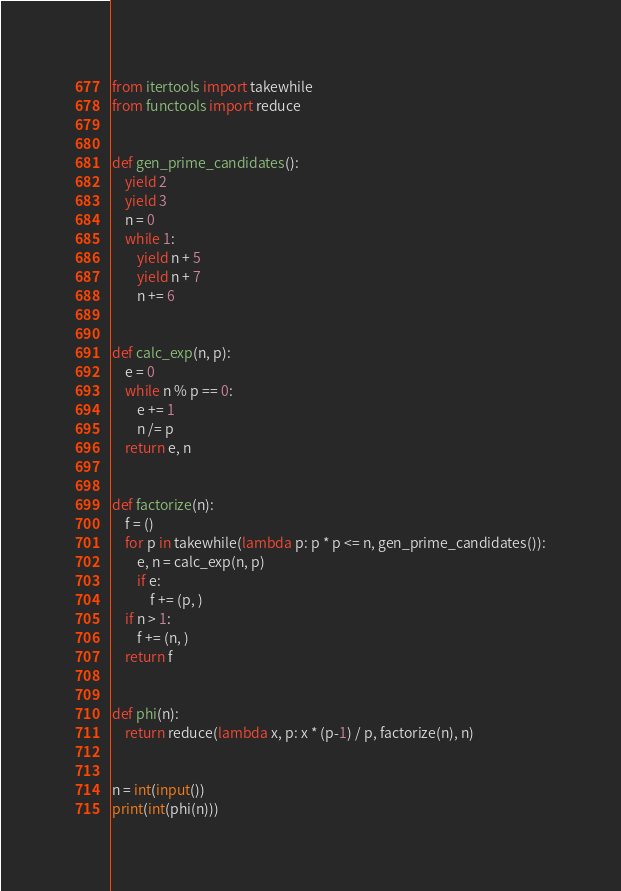<code> <loc_0><loc_0><loc_500><loc_500><_Python_>from itertools import takewhile
from functools import reduce


def gen_prime_candidates():
    yield 2
    yield 3
    n = 0
    while 1:
        yield n + 5
        yield n + 7
        n += 6


def calc_exp(n, p):
    e = 0
    while n % p == 0:
        e += 1
        n /= p
    return e, n


def factorize(n):
    f = ()
    for p in takewhile(lambda p: p * p <= n, gen_prime_candidates()):
        e, n = calc_exp(n, p)
        if e:
            f += (p, )
    if n > 1:
        f += (n, )
    return f


def phi(n):
    return reduce(lambda x, p: x * (p-1) / p, factorize(n), n)


n = int(input())
print(int(phi(n)))

</code> 